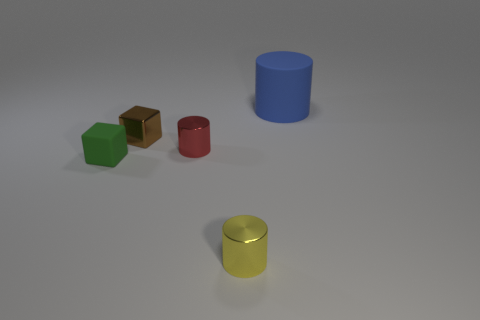Subtract all brown cubes. Subtract all purple balls. How many cubes are left? 1 Add 2 yellow matte spheres. How many objects exist? 7 Subtract all cylinders. How many objects are left? 2 Subtract 0 brown balls. How many objects are left? 5 Subtract all cyan matte blocks. Subtract all small brown shiny objects. How many objects are left? 4 Add 5 large rubber cylinders. How many large rubber cylinders are left? 6 Add 1 tiny green cubes. How many tiny green cubes exist? 2 